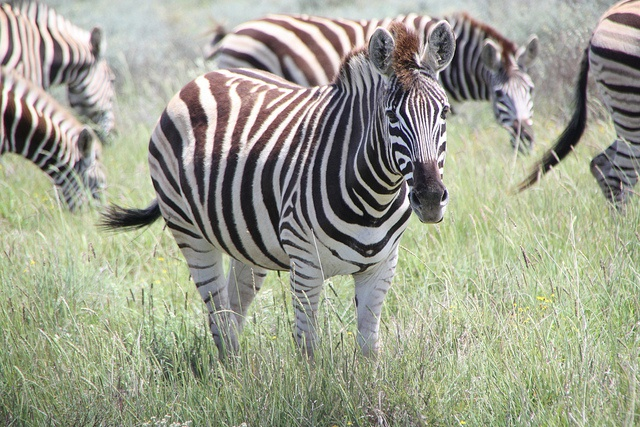Describe the objects in this image and their specific colors. I can see zebra in darkgray, black, gray, and lightgray tones, zebra in darkgray, lightgray, gray, and black tones, zebra in darkgray, gray, black, and lightgray tones, zebra in darkgray, lightgray, black, and gray tones, and zebra in darkgray, lightgray, gray, and pink tones in this image. 